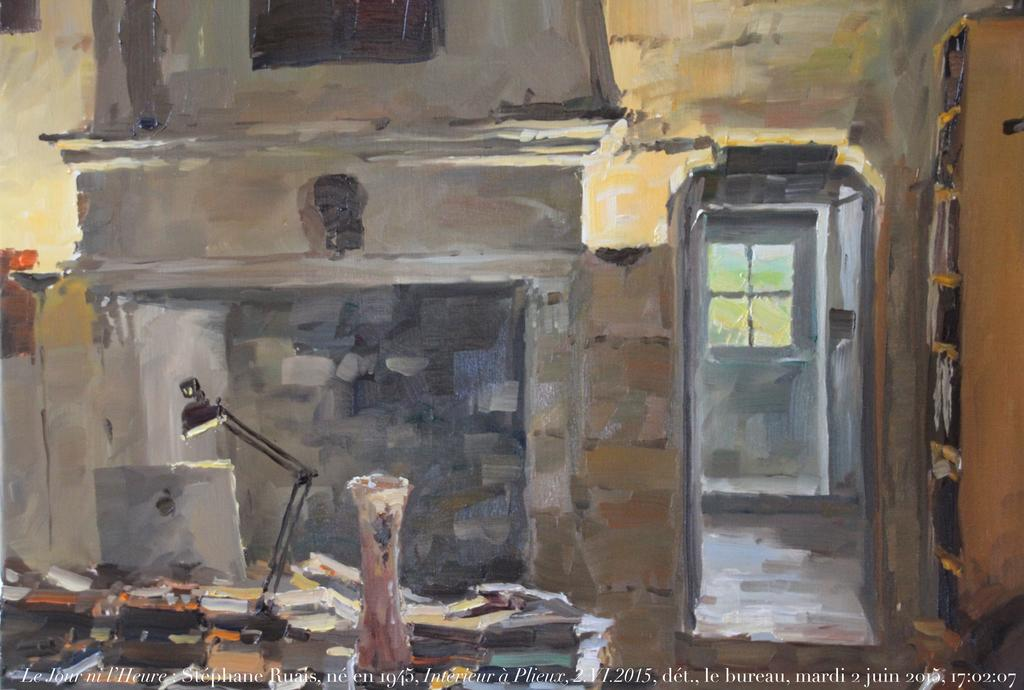<image>
Create a compact narrative representing the image presented. a painting of a desk infront of a fireplace made in 2015 